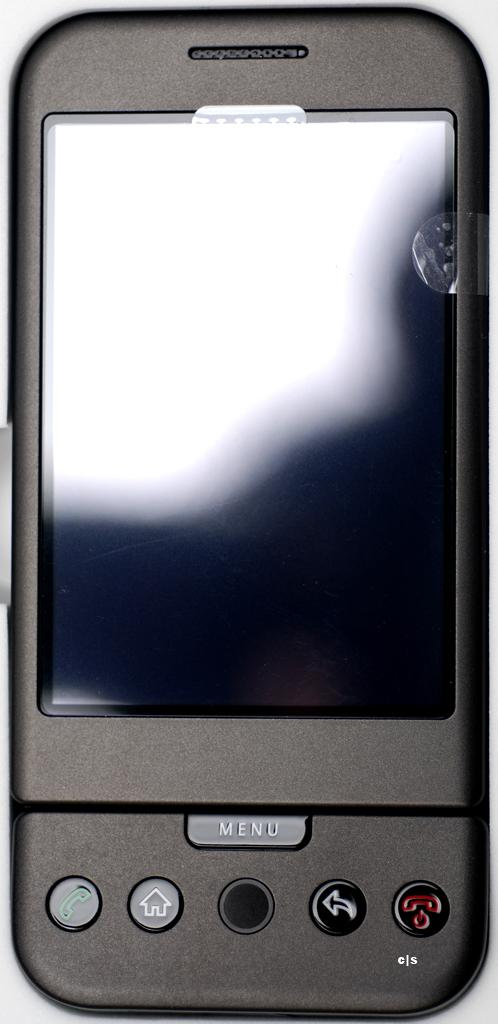<image>
Write a terse but informative summary of the picture. The generic cell phone has a silver button below the view screen that says menu. 